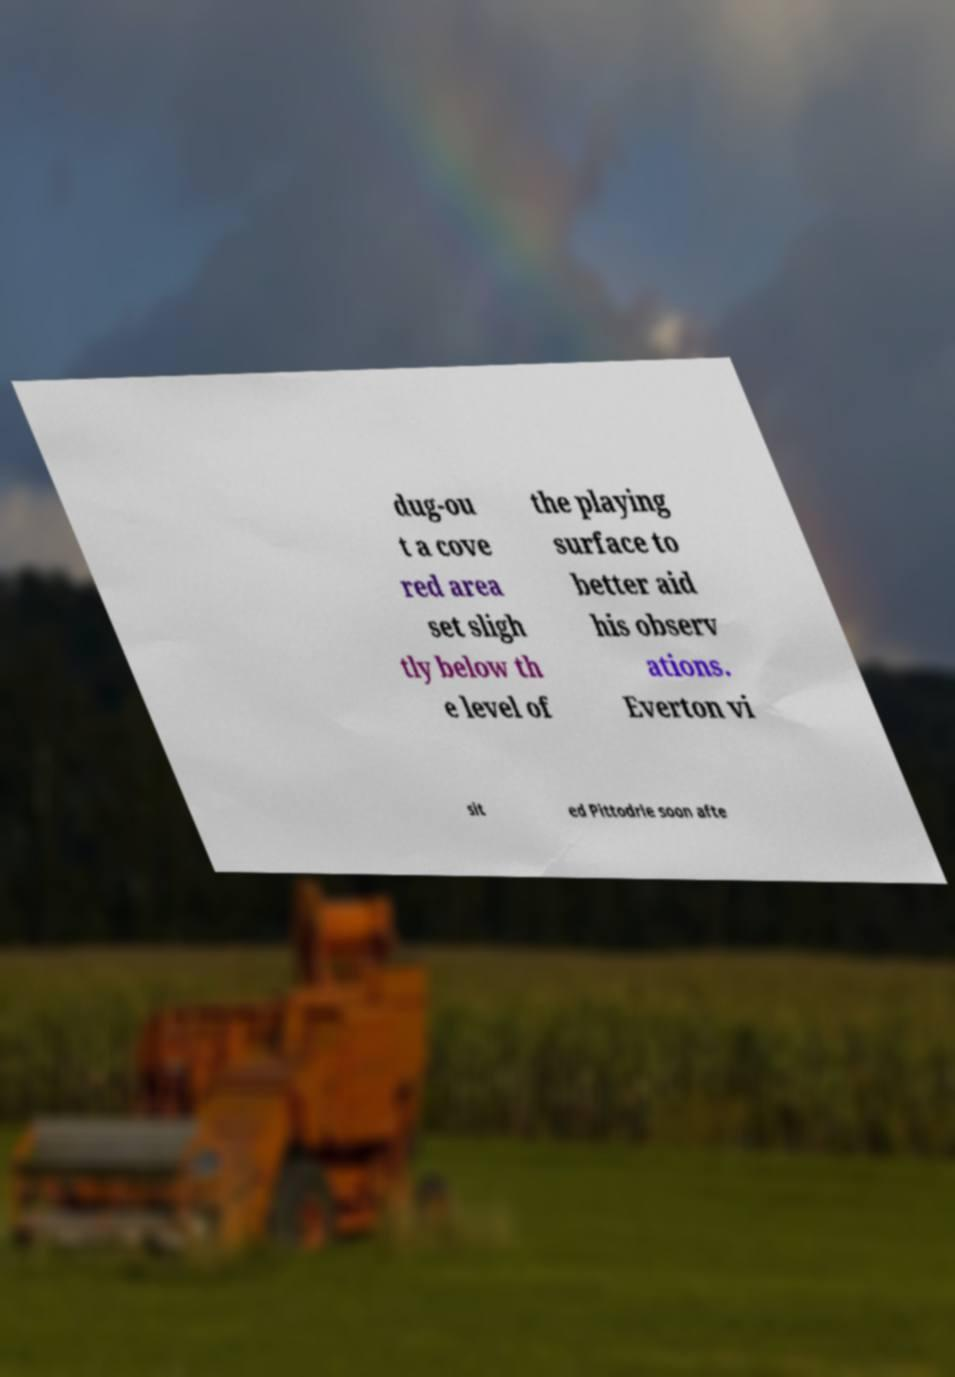I need the written content from this picture converted into text. Can you do that? dug-ou t a cove red area set sligh tly below th e level of the playing surface to better aid his observ ations. Everton vi sit ed Pittodrie soon afte 